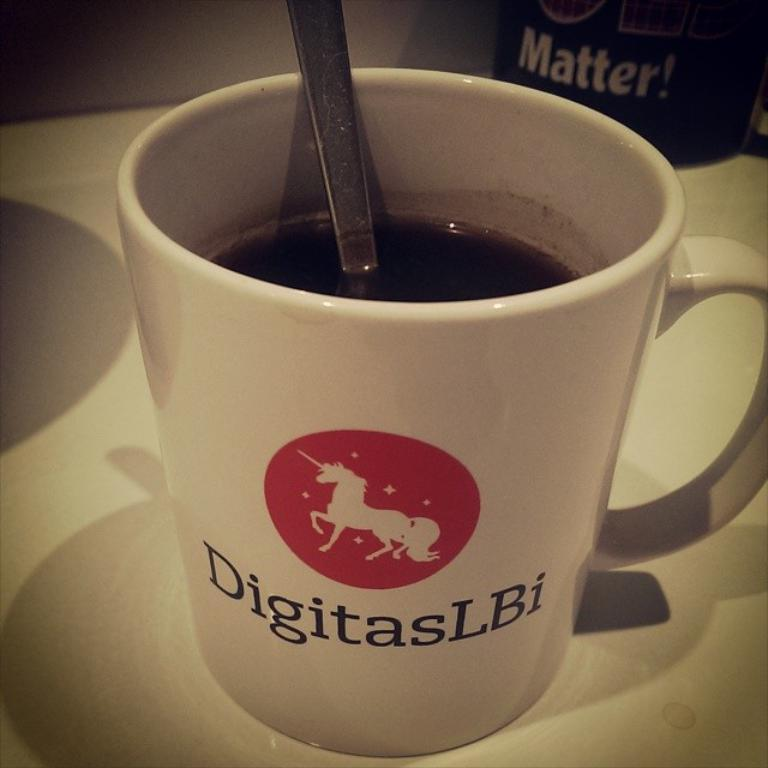<image>
Render a clear and concise summary of the photo. A spoon resting in a cup that reads DigitasLBi. 